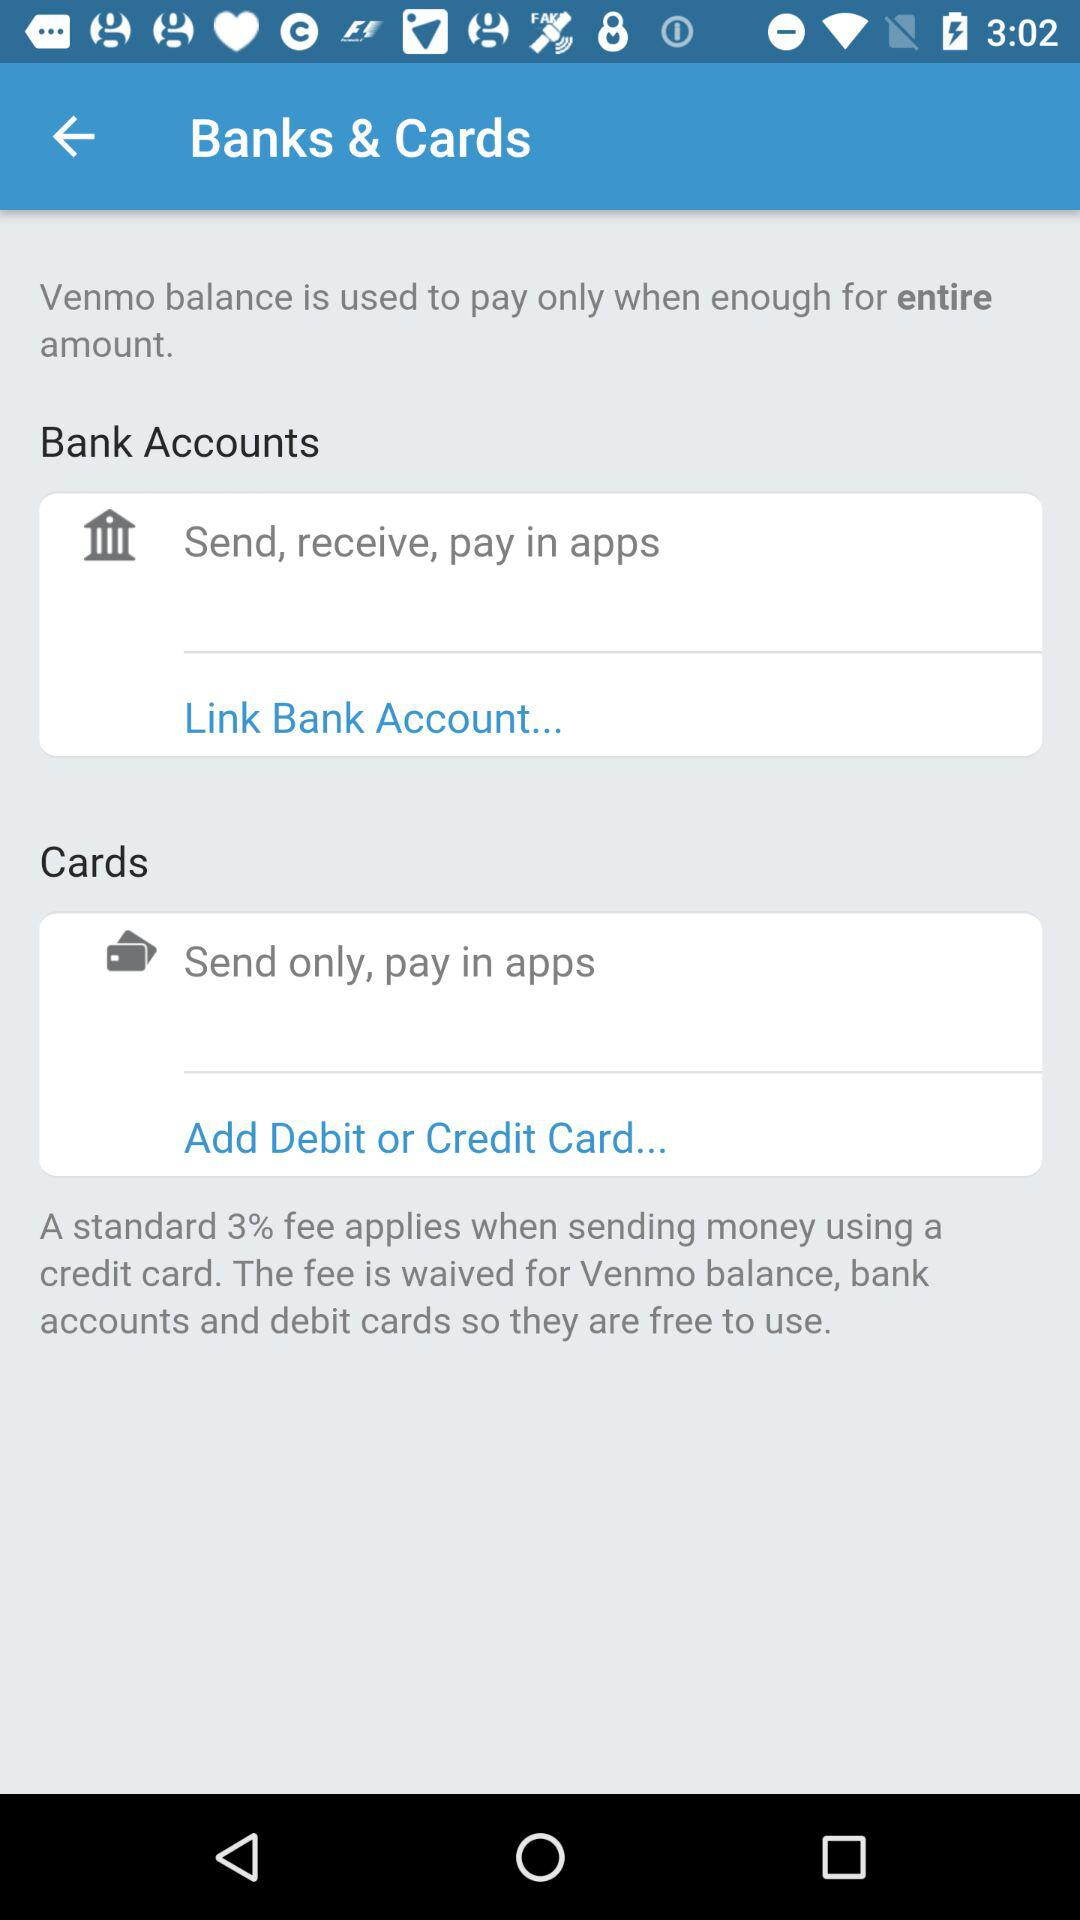What is the percentage of the standard fee? The percentage is 3. 